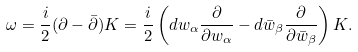<formula> <loc_0><loc_0><loc_500><loc_500>\omega = { \frac { i } { 2 } } ( \partial - \bar { \partial } ) K = { \frac { i } { 2 } } \left ( d w _ { \alpha } { \frac { \partial } { \partial w _ { \alpha } } } - d \bar { w } _ { \beta } { \frac { \partial } { \partial \bar { w } _ { \beta } } } \right ) K .</formula> 